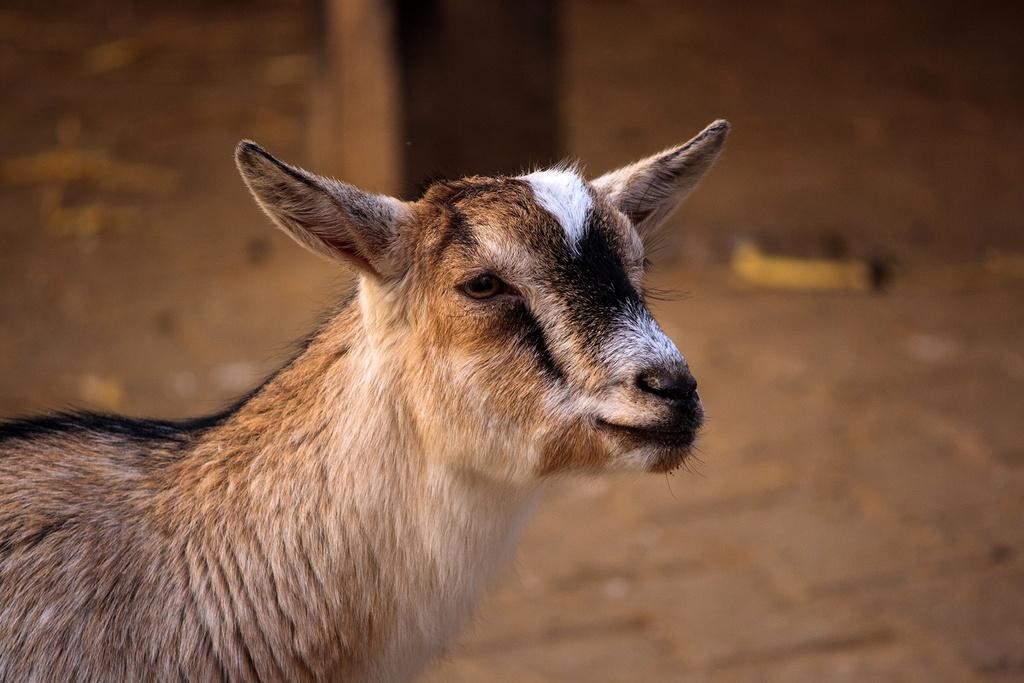Describe this image in one or two sentences. In this picture there is a goat who is standing on the ground. At the top this is a wooden pole, beside that it may be dust. 